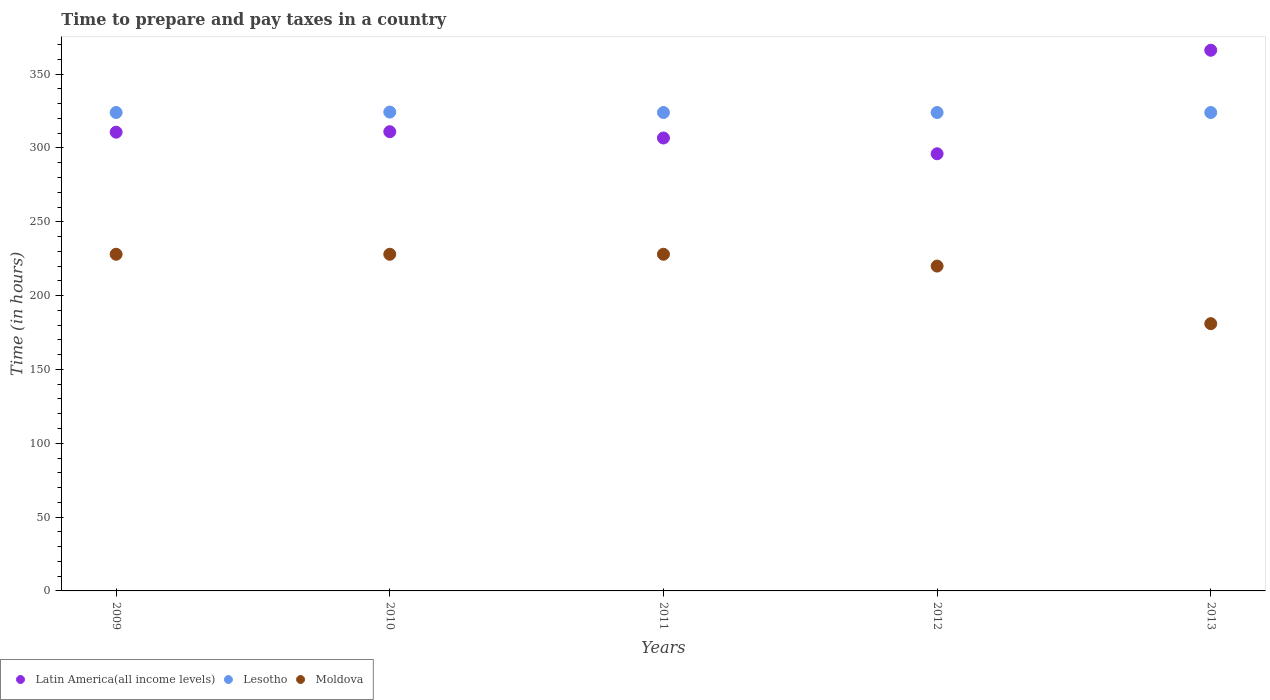Is the number of dotlines equal to the number of legend labels?
Provide a short and direct response. Yes. What is the number of hours required to prepare and pay taxes in Latin America(all income levels) in 2012?
Make the answer very short. 296.06. Across all years, what is the maximum number of hours required to prepare and pay taxes in Lesotho?
Provide a short and direct response. 324.3. Across all years, what is the minimum number of hours required to prepare and pay taxes in Lesotho?
Make the answer very short. 324. In which year was the number of hours required to prepare and pay taxes in Latin America(all income levels) maximum?
Offer a terse response. 2013. What is the total number of hours required to prepare and pay taxes in Moldova in the graph?
Give a very brief answer. 1085. What is the difference between the number of hours required to prepare and pay taxes in Lesotho in 2010 and that in 2011?
Make the answer very short. 0.3. What is the difference between the number of hours required to prepare and pay taxes in Lesotho in 2011 and the number of hours required to prepare and pay taxes in Latin America(all income levels) in 2010?
Offer a terse response. 13. What is the average number of hours required to prepare and pay taxes in Latin America(all income levels) per year?
Keep it short and to the point. 318.13. In the year 2009, what is the difference between the number of hours required to prepare and pay taxes in Lesotho and number of hours required to prepare and pay taxes in Latin America(all income levels)?
Offer a terse response. 13.32. What is the ratio of the number of hours required to prepare and pay taxes in Moldova in 2011 to that in 2013?
Keep it short and to the point. 1.26. Is the difference between the number of hours required to prepare and pay taxes in Lesotho in 2009 and 2013 greater than the difference between the number of hours required to prepare and pay taxes in Latin America(all income levels) in 2009 and 2013?
Keep it short and to the point. Yes. What is the difference between the highest and the second highest number of hours required to prepare and pay taxes in Latin America(all income levels)?
Your response must be concise. 55.17. What is the difference between the highest and the lowest number of hours required to prepare and pay taxes in Latin America(all income levels)?
Make the answer very short. 70.1. Is the sum of the number of hours required to prepare and pay taxes in Latin America(all income levels) in 2009 and 2010 greater than the maximum number of hours required to prepare and pay taxes in Moldova across all years?
Give a very brief answer. Yes. How many dotlines are there?
Offer a terse response. 3. How many years are there in the graph?
Your answer should be very brief. 5. Are the values on the major ticks of Y-axis written in scientific E-notation?
Your answer should be compact. No. Does the graph contain any zero values?
Provide a succinct answer. No. Where does the legend appear in the graph?
Make the answer very short. Bottom left. How many legend labels are there?
Give a very brief answer. 3. What is the title of the graph?
Give a very brief answer. Time to prepare and pay taxes in a country. What is the label or title of the X-axis?
Ensure brevity in your answer.  Years. What is the label or title of the Y-axis?
Provide a short and direct response. Time (in hours). What is the Time (in hours) in Latin America(all income levels) in 2009?
Your answer should be very brief. 310.68. What is the Time (in hours) of Lesotho in 2009?
Offer a very short reply. 324. What is the Time (in hours) in Moldova in 2009?
Provide a succinct answer. 228. What is the Time (in hours) of Latin America(all income levels) in 2010?
Keep it short and to the point. 311. What is the Time (in hours) of Lesotho in 2010?
Give a very brief answer. 324.3. What is the Time (in hours) of Moldova in 2010?
Ensure brevity in your answer.  228. What is the Time (in hours) of Latin America(all income levels) in 2011?
Give a very brief answer. 306.74. What is the Time (in hours) in Lesotho in 2011?
Your answer should be compact. 324. What is the Time (in hours) in Moldova in 2011?
Keep it short and to the point. 228. What is the Time (in hours) of Latin America(all income levels) in 2012?
Offer a very short reply. 296.06. What is the Time (in hours) of Lesotho in 2012?
Offer a very short reply. 324. What is the Time (in hours) of Moldova in 2012?
Your answer should be compact. 220. What is the Time (in hours) of Latin America(all income levels) in 2013?
Your answer should be compact. 366.17. What is the Time (in hours) in Lesotho in 2013?
Provide a short and direct response. 324. What is the Time (in hours) of Moldova in 2013?
Your response must be concise. 181. Across all years, what is the maximum Time (in hours) of Latin America(all income levels)?
Make the answer very short. 366.17. Across all years, what is the maximum Time (in hours) in Lesotho?
Keep it short and to the point. 324.3. Across all years, what is the maximum Time (in hours) of Moldova?
Offer a terse response. 228. Across all years, what is the minimum Time (in hours) of Latin America(all income levels)?
Ensure brevity in your answer.  296.06. Across all years, what is the minimum Time (in hours) of Lesotho?
Your answer should be very brief. 324. Across all years, what is the minimum Time (in hours) of Moldova?
Make the answer very short. 181. What is the total Time (in hours) in Latin America(all income levels) in the graph?
Offer a very short reply. 1590.65. What is the total Time (in hours) of Lesotho in the graph?
Your answer should be compact. 1620.3. What is the total Time (in hours) in Moldova in the graph?
Provide a short and direct response. 1085. What is the difference between the Time (in hours) of Latin America(all income levels) in 2009 and that in 2010?
Give a very brief answer. -0.32. What is the difference between the Time (in hours) in Moldova in 2009 and that in 2010?
Your answer should be very brief. 0. What is the difference between the Time (in hours) of Latin America(all income levels) in 2009 and that in 2011?
Offer a terse response. 3.93. What is the difference between the Time (in hours) in Latin America(all income levels) in 2009 and that in 2012?
Keep it short and to the point. 14.61. What is the difference between the Time (in hours) in Latin America(all income levels) in 2009 and that in 2013?
Your response must be concise. -55.49. What is the difference between the Time (in hours) of Moldova in 2009 and that in 2013?
Keep it short and to the point. 47. What is the difference between the Time (in hours) of Latin America(all income levels) in 2010 and that in 2011?
Your response must be concise. 4.26. What is the difference between the Time (in hours) of Lesotho in 2010 and that in 2011?
Make the answer very short. 0.3. What is the difference between the Time (in hours) of Latin America(all income levels) in 2010 and that in 2012?
Give a very brief answer. 14.94. What is the difference between the Time (in hours) in Lesotho in 2010 and that in 2012?
Ensure brevity in your answer.  0.3. What is the difference between the Time (in hours) of Moldova in 2010 and that in 2012?
Provide a succinct answer. 8. What is the difference between the Time (in hours) in Latin America(all income levels) in 2010 and that in 2013?
Your answer should be compact. -55.17. What is the difference between the Time (in hours) of Latin America(all income levels) in 2011 and that in 2012?
Offer a terse response. 10.68. What is the difference between the Time (in hours) in Moldova in 2011 and that in 2012?
Your response must be concise. 8. What is the difference between the Time (in hours) of Latin America(all income levels) in 2011 and that in 2013?
Provide a succinct answer. -59.42. What is the difference between the Time (in hours) of Lesotho in 2011 and that in 2013?
Give a very brief answer. 0. What is the difference between the Time (in hours) of Moldova in 2011 and that in 2013?
Your answer should be compact. 47. What is the difference between the Time (in hours) in Latin America(all income levels) in 2012 and that in 2013?
Provide a short and direct response. -70.1. What is the difference between the Time (in hours) in Lesotho in 2012 and that in 2013?
Your answer should be very brief. 0. What is the difference between the Time (in hours) in Moldova in 2012 and that in 2013?
Your response must be concise. 39. What is the difference between the Time (in hours) of Latin America(all income levels) in 2009 and the Time (in hours) of Lesotho in 2010?
Your response must be concise. -13.62. What is the difference between the Time (in hours) in Latin America(all income levels) in 2009 and the Time (in hours) in Moldova in 2010?
Offer a very short reply. 82.68. What is the difference between the Time (in hours) of Lesotho in 2009 and the Time (in hours) of Moldova in 2010?
Make the answer very short. 96. What is the difference between the Time (in hours) in Latin America(all income levels) in 2009 and the Time (in hours) in Lesotho in 2011?
Your answer should be compact. -13.32. What is the difference between the Time (in hours) of Latin America(all income levels) in 2009 and the Time (in hours) of Moldova in 2011?
Give a very brief answer. 82.68. What is the difference between the Time (in hours) in Lesotho in 2009 and the Time (in hours) in Moldova in 2011?
Your response must be concise. 96. What is the difference between the Time (in hours) of Latin America(all income levels) in 2009 and the Time (in hours) of Lesotho in 2012?
Keep it short and to the point. -13.32. What is the difference between the Time (in hours) in Latin America(all income levels) in 2009 and the Time (in hours) in Moldova in 2012?
Your answer should be very brief. 90.68. What is the difference between the Time (in hours) of Lesotho in 2009 and the Time (in hours) of Moldova in 2012?
Offer a terse response. 104. What is the difference between the Time (in hours) in Latin America(all income levels) in 2009 and the Time (in hours) in Lesotho in 2013?
Provide a succinct answer. -13.32. What is the difference between the Time (in hours) of Latin America(all income levels) in 2009 and the Time (in hours) of Moldova in 2013?
Offer a terse response. 129.68. What is the difference between the Time (in hours) in Lesotho in 2009 and the Time (in hours) in Moldova in 2013?
Provide a short and direct response. 143. What is the difference between the Time (in hours) in Lesotho in 2010 and the Time (in hours) in Moldova in 2011?
Ensure brevity in your answer.  96.3. What is the difference between the Time (in hours) in Latin America(all income levels) in 2010 and the Time (in hours) in Lesotho in 2012?
Your answer should be very brief. -13. What is the difference between the Time (in hours) in Latin America(all income levels) in 2010 and the Time (in hours) in Moldova in 2012?
Ensure brevity in your answer.  91. What is the difference between the Time (in hours) of Lesotho in 2010 and the Time (in hours) of Moldova in 2012?
Give a very brief answer. 104.3. What is the difference between the Time (in hours) of Latin America(all income levels) in 2010 and the Time (in hours) of Lesotho in 2013?
Make the answer very short. -13. What is the difference between the Time (in hours) of Latin America(all income levels) in 2010 and the Time (in hours) of Moldova in 2013?
Provide a succinct answer. 130. What is the difference between the Time (in hours) of Lesotho in 2010 and the Time (in hours) of Moldova in 2013?
Your answer should be very brief. 143.3. What is the difference between the Time (in hours) of Latin America(all income levels) in 2011 and the Time (in hours) of Lesotho in 2012?
Your answer should be compact. -17.26. What is the difference between the Time (in hours) in Latin America(all income levels) in 2011 and the Time (in hours) in Moldova in 2012?
Offer a very short reply. 86.74. What is the difference between the Time (in hours) in Lesotho in 2011 and the Time (in hours) in Moldova in 2012?
Your answer should be compact. 104. What is the difference between the Time (in hours) of Latin America(all income levels) in 2011 and the Time (in hours) of Lesotho in 2013?
Provide a succinct answer. -17.26. What is the difference between the Time (in hours) of Latin America(all income levels) in 2011 and the Time (in hours) of Moldova in 2013?
Offer a terse response. 125.74. What is the difference between the Time (in hours) of Lesotho in 2011 and the Time (in hours) of Moldova in 2013?
Provide a short and direct response. 143. What is the difference between the Time (in hours) in Latin America(all income levels) in 2012 and the Time (in hours) in Lesotho in 2013?
Give a very brief answer. -27.94. What is the difference between the Time (in hours) in Latin America(all income levels) in 2012 and the Time (in hours) in Moldova in 2013?
Your answer should be compact. 115.06. What is the difference between the Time (in hours) of Lesotho in 2012 and the Time (in hours) of Moldova in 2013?
Your answer should be very brief. 143. What is the average Time (in hours) in Latin America(all income levels) per year?
Ensure brevity in your answer.  318.13. What is the average Time (in hours) in Lesotho per year?
Your response must be concise. 324.06. What is the average Time (in hours) in Moldova per year?
Your response must be concise. 217. In the year 2009, what is the difference between the Time (in hours) of Latin America(all income levels) and Time (in hours) of Lesotho?
Offer a terse response. -13.32. In the year 2009, what is the difference between the Time (in hours) in Latin America(all income levels) and Time (in hours) in Moldova?
Give a very brief answer. 82.68. In the year 2009, what is the difference between the Time (in hours) in Lesotho and Time (in hours) in Moldova?
Your answer should be very brief. 96. In the year 2010, what is the difference between the Time (in hours) of Latin America(all income levels) and Time (in hours) of Lesotho?
Ensure brevity in your answer.  -13.3. In the year 2010, what is the difference between the Time (in hours) of Lesotho and Time (in hours) of Moldova?
Keep it short and to the point. 96.3. In the year 2011, what is the difference between the Time (in hours) of Latin America(all income levels) and Time (in hours) of Lesotho?
Provide a succinct answer. -17.26. In the year 2011, what is the difference between the Time (in hours) of Latin America(all income levels) and Time (in hours) of Moldova?
Offer a terse response. 78.74. In the year 2011, what is the difference between the Time (in hours) in Lesotho and Time (in hours) in Moldova?
Your answer should be very brief. 96. In the year 2012, what is the difference between the Time (in hours) of Latin America(all income levels) and Time (in hours) of Lesotho?
Keep it short and to the point. -27.94. In the year 2012, what is the difference between the Time (in hours) in Latin America(all income levels) and Time (in hours) in Moldova?
Make the answer very short. 76.06. In the year 2012, what is the difference between the Time (in hours) of Lesotho and Time (in hours) of Moldova?
Give a very brief answer. 104. In the year 2013, what is the difference between the Time (in hours) of Latin America(all income levels) and Time (in hours) of Lesotho?
Keep it short and to the point. 42.17. In the year 2013, what is the difference between the Time (in hours) in Latin America(all income levels) and Time (in hours) in Moldova?
Offer a terse response. 185.17. In the year 2013, what is the difference between the Time (in hours) of Lesotho and Time (in hours) of Moldova?
Provide a succinct answer. 143. What is the ratio of the Time (in hours) in Lesotho in 2009 to that in 2010?
Provide a succinct answer. 1. What is the ratio of the Time (in hours) of Moldova in 2009 to that in 2010?
Your answer should be very brief. 1. What is the ratio of the Time (in hours) of Latin America(all income levels) in 2009 to that in 2011?
Keep it short and to the point. 1.01. What is the ratio of the Time (in hours) of Lesotho in 2009 to that in 2011?
Your answer should be very brief. 1. What is the ratio of the Time (in hours) of Latin America(all income levels) in 2009 to that in 2012?
Ensure brevity in your answer.  1.05. What is the ratio of the Time (in hours) in Lesotho in 2009 to that in 2012?
Ensure brevity in your answer.  1. What is the ratio of the Time (in hours) of Moldova in 2009 to that in 2012?
Your response must be concise. 1.04. What is the ratio of the Time (in hours) in Latin America(all income levels) in 2009 to that in 2013?
Offer a very short reply. 0.85. What is the ratio of the Time (in hours) in Moldova in 2009 to that in 2013?
Offer a very short reply. 1.26. What is the ratio of the Time (in hours) of Latin America(all income levels) in 2010 to that in 2011?
Provide a short and direct response. 1.01. What is the ratio of the Time (in hours) of Lesotho in 2010 to that in 2011?
Offer a very short reply. 1. What is the ratio of the Time (in hours) of Latin America(all income levels) in 2010 to that in 2012?
Keep it short and to the point. 1.05. What is the ratio of the Time (in hours) of Moldova in 2010 to that in 2012?
Your response must be concise. 1.04. What is the ratio of the Time (in hours) in Latin America(all income levels) in 2010 to that in 2013?
Offer a terse response. 0.85. What is the ratio of the Time (in hours) of Lesotho in 2010 to that in 2013?
Provide a succinct answer. 1. What is the ratio of the Time (in hours) in Moldova in 2010 to that in 2013?
Offer a terse response. 1.26. What is the ratio of the Time (in hours) in Latin America(all income levels) in 2011 to that in 2012?
Give a very brief answer. 1.04. What is the ratio of the Time (in hours) in Moldova in 2011 to that in 2012?
Your answer should be very brief. 1.04. What is the ratio of the Time (in hours) of Latin America(all income levels) in 2011 to that in 2013?
Provide a succinct answer. 0.84. What is the ratio of the Time (in hours) of Moldova in 2011 to that in 2013?
Your answer should be compact. 1.26. What is the ratio of the Time (in hours) of Latin America(all income levels) in 2012 to that in 2013?
Keep it short and to the point. 0.81. What is the ratio of the Time (in hours) in Moldova in 2012 to that in 2013?
Your answer should be compact. 1.22. What is the difference between the highest and the second highest Time (in hours) in Latin America(all income levels)?
Ensure brevity in your answer.  55.17. What is the difference between the highest and the lowest Time (in hours) in Latin America(all income levels)?
Provide a short and direct response. 70.1. What is the difference between the highest and the lowest Time (in hours) in Lesotho?
Give a very brief answer. 0.3. What is the difference between the highest and the lowest Time (in hours) of Moldova?
Provide a short and direct response. 47. 